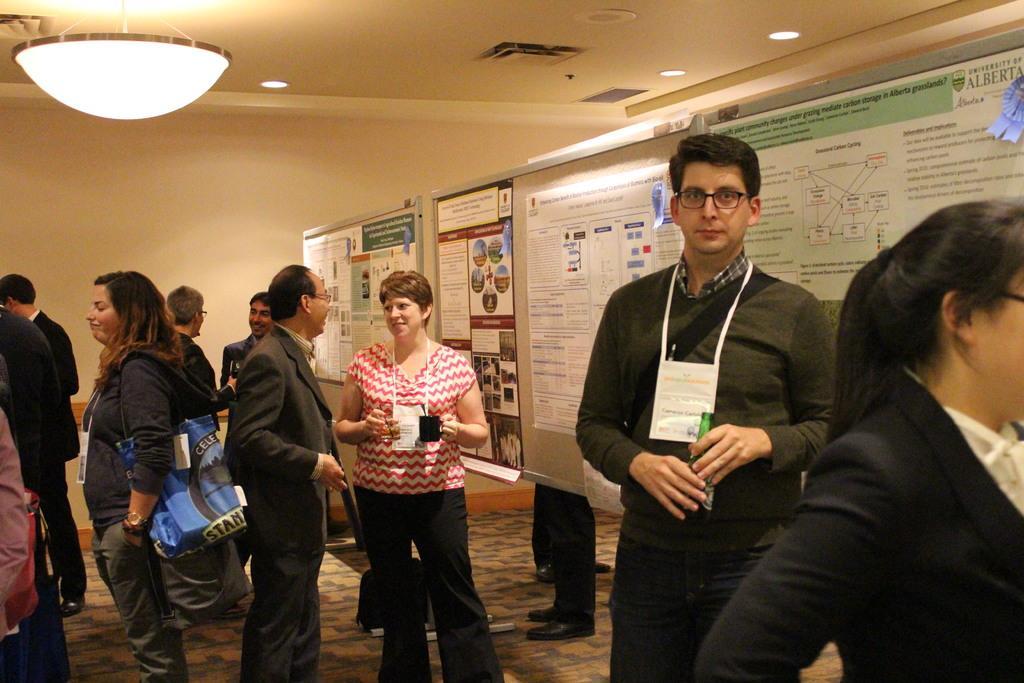Describe this image in one or two sentences. In this image, we can see a group of people are standing on the floor. Here we can see few people are holding some objects. Here a person is watching and wearing glasses. In the background, we can see posters, walls. Top of the image, we can see the ceiling and lights. 